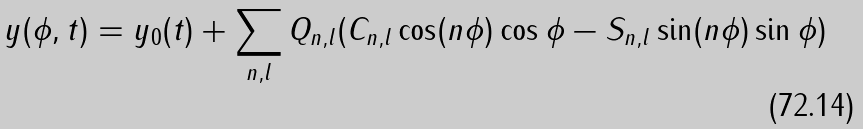Convert formula to latex. <formula><loc_0><loc_0><loc_500><loc_500>y ( \phi , t ) = y _ { 0 } ( t ) + \sum _ { n , l } Q _ { n , l } ( C _ { n , l } \cos ( n \phi ) \cos \phi - S _ { n , l } \sin ( n \phi ) \sin \phi )</formula> 